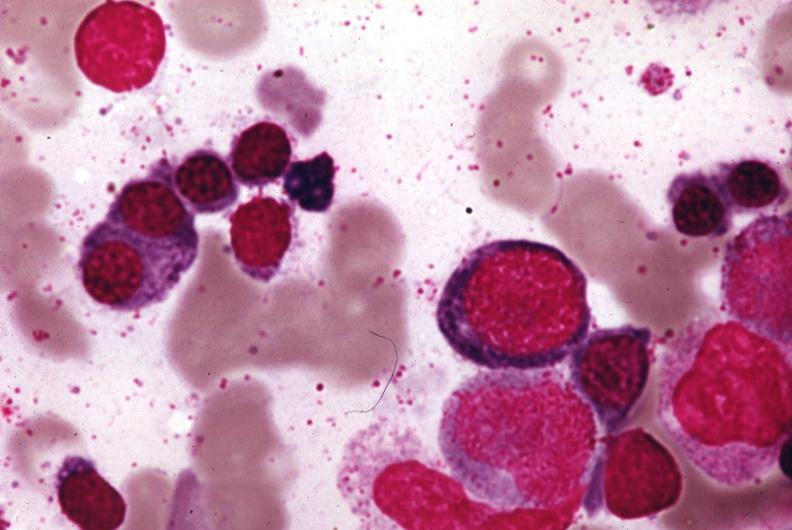what is present?
Answer the question using a single word or phrase. Bone marrow 